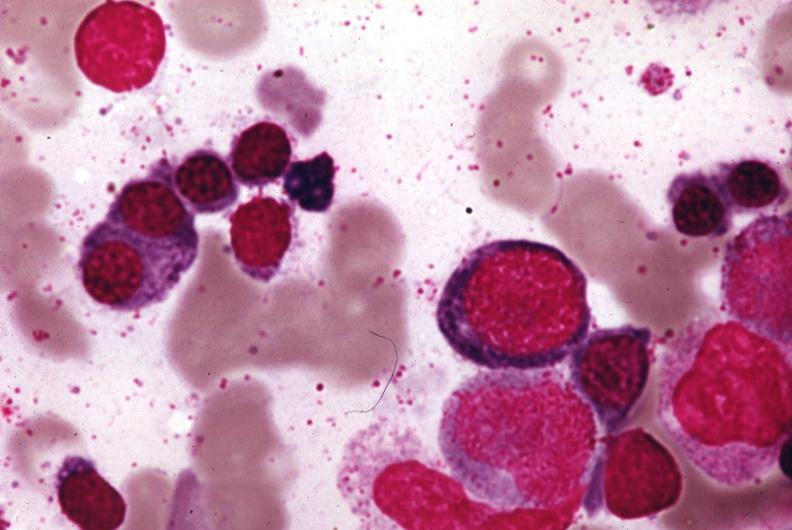what is present?
Answer the question using a single word or phrase. Bone marrow 